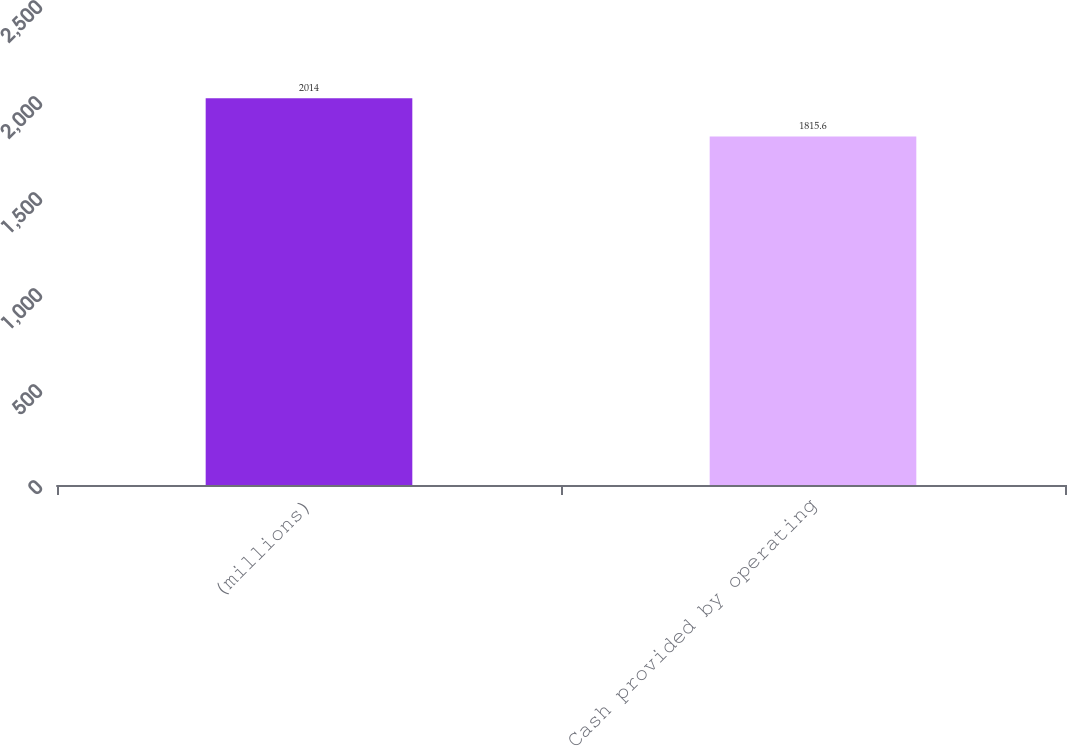Convert chart. <chart><loc_0><loc_0><loc_500><loc_500><bar_chart><fcel>(millions)<fcel>Cash provided by operating<nl><fcel>2014<fcel>1815.6<nl></chart> 